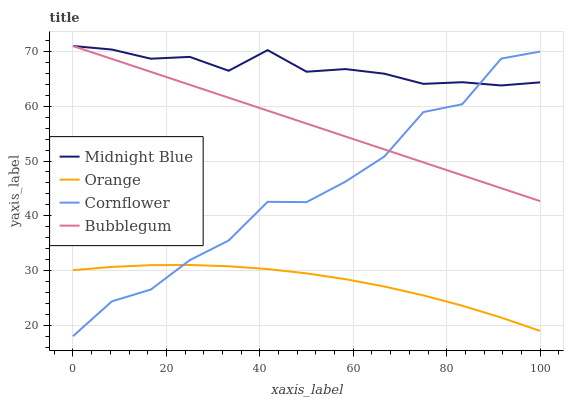Does Orange have the minimum area under the curve?
Answer yes or no. Yes. Does Midnight Blue have the maximum area under the curve?
Answer yes or no. Yes. Does Cornflower have the minimum area under the curve?
Answer yes or no. No. Does Cornflower have the maximum area under the curve?
Answer yes or no. No. Is Bubblegum the smoothest?
Answer yes or no. Yes. Is Cornflower the roughest?
Answer yes or no. Yes. Is Midnight Blue the smoothest?
Answer yes or no. No. Is Midnight Blue the roughest?
Answer yes or no. No. Does Cornflower have the lowest value?
Answer yes or no. Yes. Does Midnight Blue have the lowest value?
Answer yes or no. No. Does Bubblegum have the highest value?
Answer yes or no. Yes. Does Cornflower have the highest value?
Answer yes or no. No. Is Orange less than Midnight Blue?
Answer yes or no. Yes. Is Midnight Blue greater than Orange?
Answer yes or no. Yes. Does Cornflower intersect Midnight Blue?
Answer yes or no. Yes. Is Cornflower less than Midnight Blue?
Answer yes or no. No. Is Cornflower greater than Midnight Blue?
Answer yes or no. No. Does Orange intersect Midnight Blue?
Answer yes or no. No. 